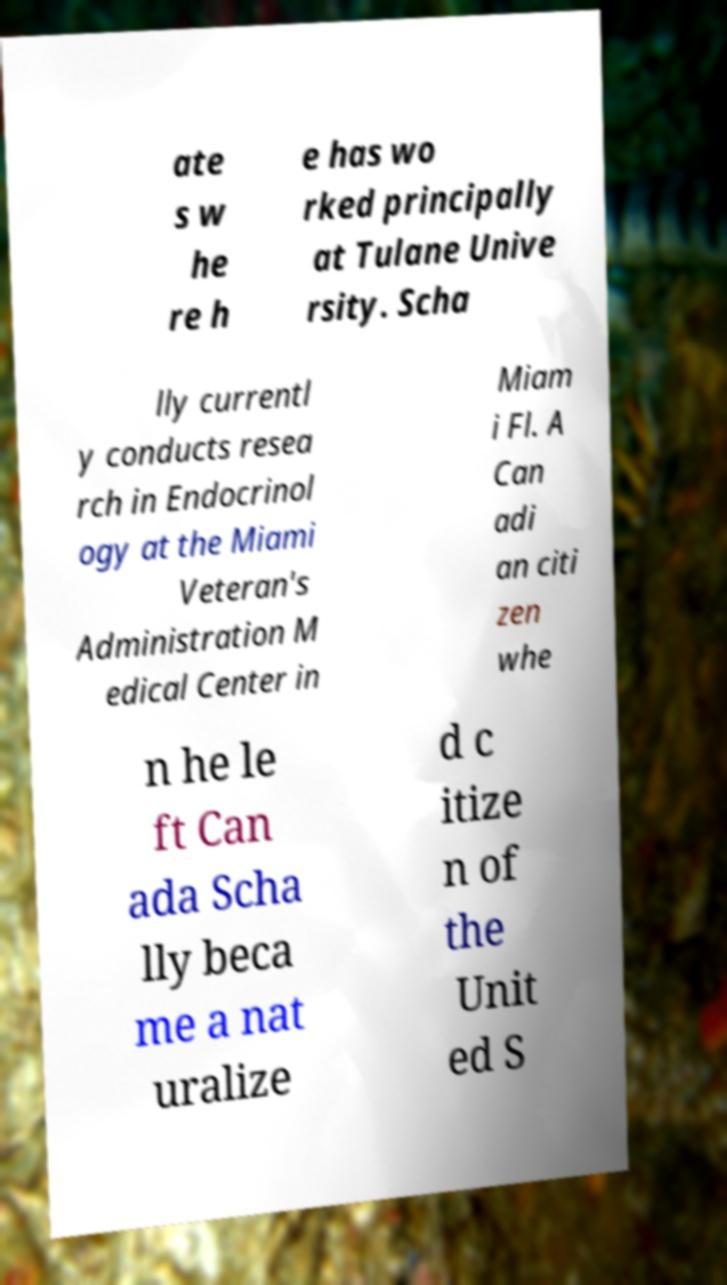Can you accurately transcribe the text from the provided image for me? ate s w he re h e has wo rked principally at Tulane Unive rsity. Scha lly currentl y conducts resea rch in Endocrinol ogy at the Miami Veteran's Administration M edical Center in Miam i Fl. A Can adi an citi zen whe n he le ft Can ada Scha lly beca me a nat uralize d c itize n of the Unit ed S 